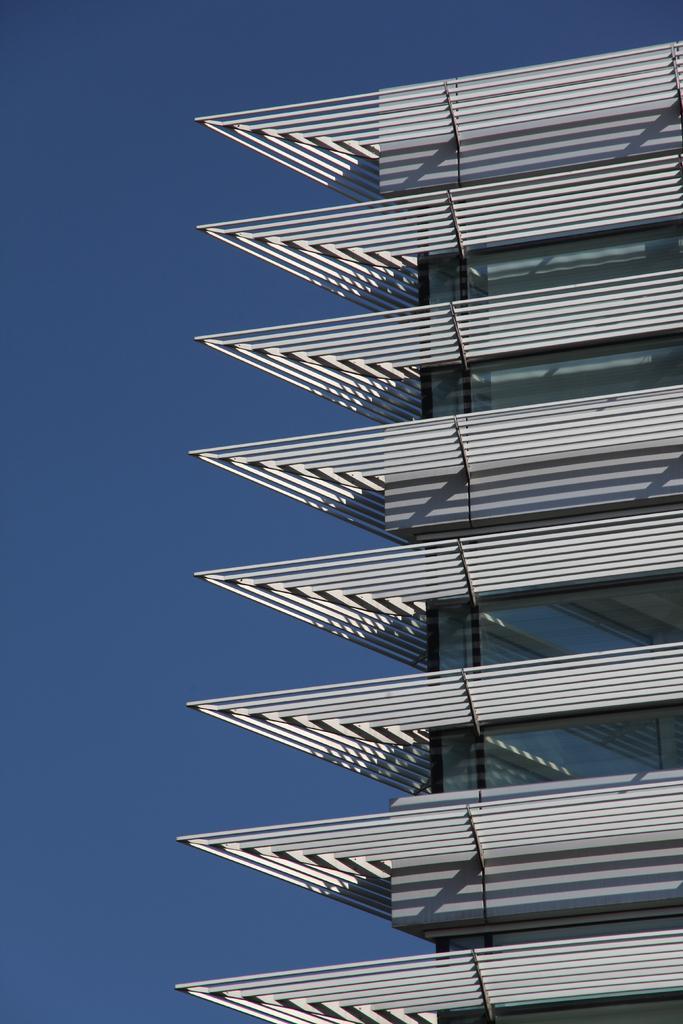In one or two sentences, can you explain what this image depicts? In this image there is an architectural building, and in the background there is sky. 